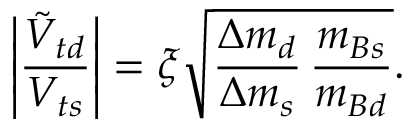<formula> <loc_0><loc_0><loc_500><loc_500>\left | \frac { \tilde { V } _ { t d } } { V _ { t s } } \right | = \xi \sqrt { \frac { \Delta m _ { d } } { \Delta m _ { s } } \, \frac { m _ { B s } } { m _ { B d } } } .</formula> 